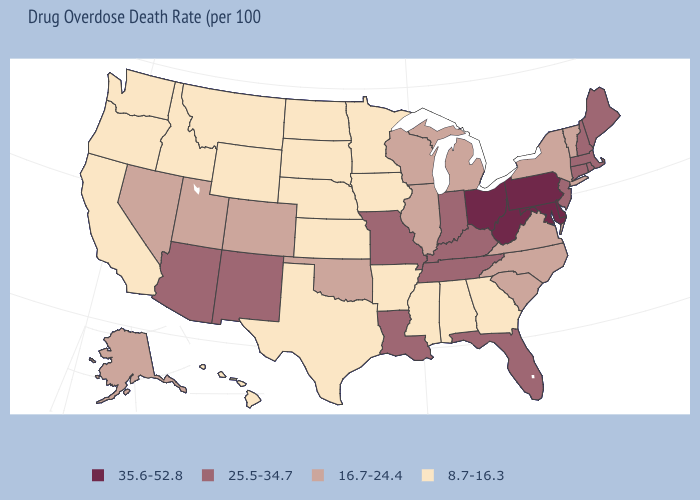How many symbols are there in the legend?
Give a very brief answer. 4. Among the states that border South Dakota , which have the lowest value?
Write a very short answer. Iowa, Minnesota, Montana, Nebraska, North Dakota, Wyoming. Does Arizona have the highest value in the West?
Give a very brief answer. Yes. What is the value of Vermont?
Concise answer only. 16.7-24.4. What is the value of Maryland?
Short answer required. 35.6-52.8. What is the value of Tennessee?
Keep it brief. 25.5-34.7. Among the states that border Washington , which have the highest value?
Short answer required. Idaho, Oregon. Name the states that have a value in the range 35.6-52.8?
Keep it brief. Delaware, Maryland, Ohio, Pennsylvania, West Virginia. Name the states that have a value in the range 25.5-34.7?
Short answer required. Arizona, Connecticut, Florida, Indiana, Kentucky, Louisiana, Maine, Massachusetts, Missouri, New Hampshire, New Jersey, New Mexico, Rhode Island, Tennessee. Which states have the lowest value in the South?
Keep it brief. Alabama, Arkansas, Georgia, Mississippi, Texas. What is the value of Michigan?
Write a very short answer. 16.7-24.4. Name the states that have a value in the range 35.6-52.8?
Keep it brief. Delaware, Maryland, Ohio, Pennsylvania, West Virginia. Name the states that have a value in the range 8.7-16.3?
Quick response, please. Alabama, Arkansas, California, Georgia, Hawaii, Idaho, Iowa, Kansas, Minnesota, Mississippi, Montana, Nebraska, North Dakota, Oregon, South Dakota, Texas, Washington, Wyoming. What is the value of Massachusetts?
Concise answer only. 25.5-34.7. Name the states that have a value in the range 25.5-34.7?
Short answer required. Arizona, Connecticut, Florida, Indiana, Kentucky, Louisiana, Maine, Massachusetts, Missouri, New Hampshire, New Jersey, New Mexico, Rhode Island, Tennessee. 